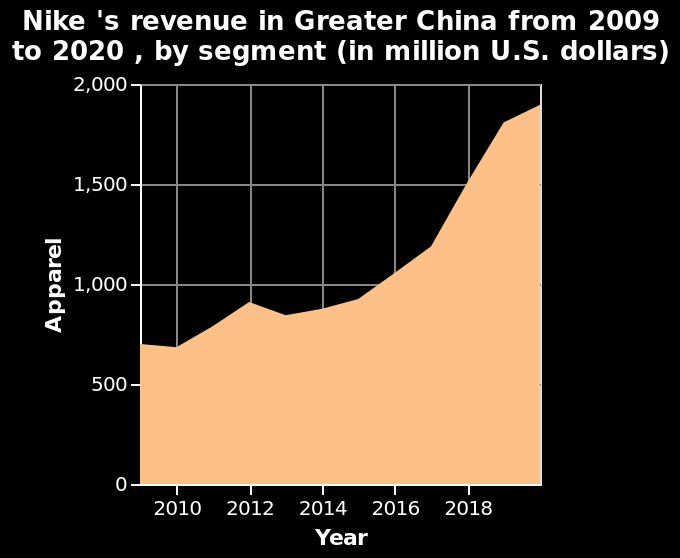<image>
Offer a thorough analysis of the image. I am not sure what apparel means in the context of revenue. However, apparel has been slowly increasing over time, with the rate of change increasing 2017-2019. 